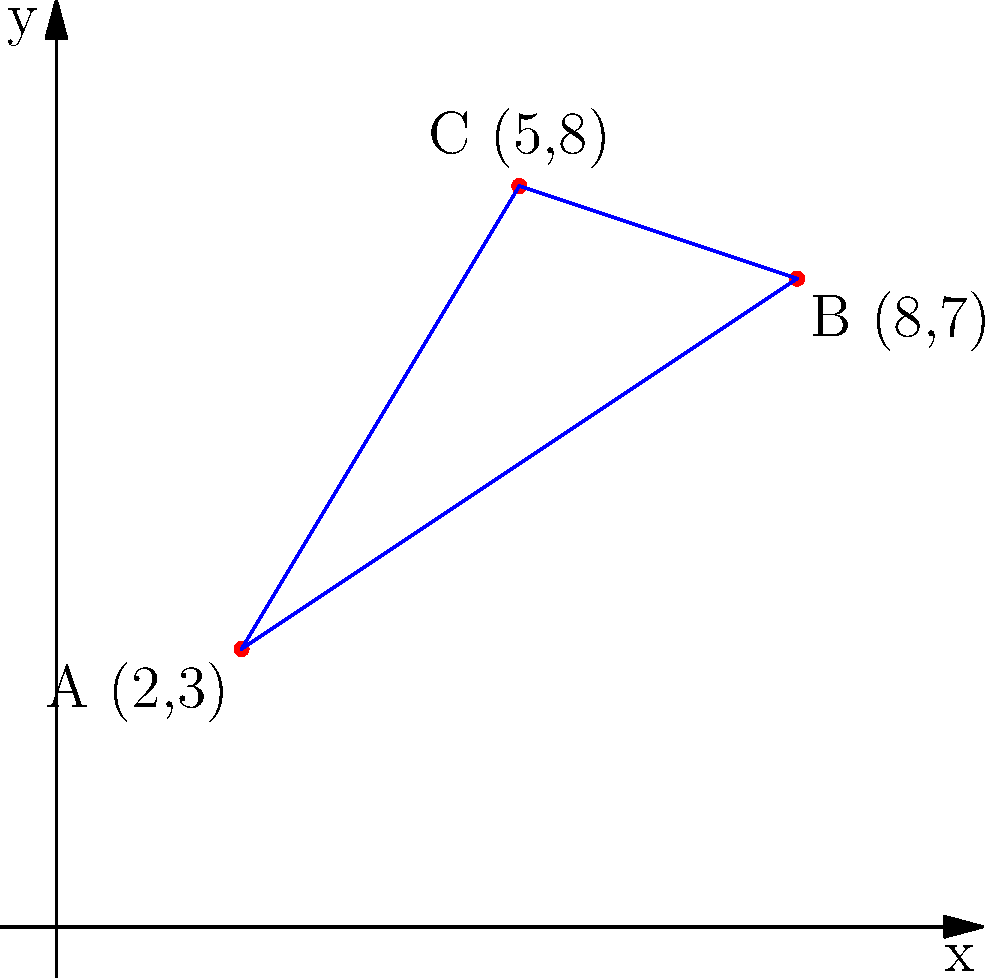Three rubber processing facilities are located at points A(2,3), B(8,7), and C(5,8) on a coordinate grid. To optimize transportation routes, you need to find the shortest path connecting all three facilities. What is the total length of this optimal path to the nearest tenth of a unit? To find the shortest path connecting all three facilities, we need to calculate the distances between each pair of points and find the sum of the two shortest distances. This will form a path that connects all three points with the minimum total distance.

Step 1: Calculate the distance between each pair of points using the distance formula:
$d = \sqrt{(x_2-x_1)^2 + (y_2-y_1)^2}$

Distance AB: $d_{AB} = \sqrt{(8-2)^2 + (7-3)^2} = \sqrt{36 + 16} = \sqrt{52} \approx 7.21$ units

Distance BC: $d_{BC} = \sqrt{(5-8)^2 + (8-7)^2} = \sqrt{9 + 1} = \sqrt{10} \approx 3.16$ units

Distance AC: $d_{AC} = \sqrt{(5-2)^2 + (8-3)^2} = \sqrt{9 + 25} = \sqrt{34} \approx 5.83$ units

Step 2: Identify the two shortest distances:
The two shortest distances are BC (3.16 units) and AC (5.83 units).

Step 3: Calculate the total length of the optimal path:
Total length = BC + AC = 3.16 + 5.83 = 8.99 units

Step 4: Round to the nearest tenth:
8.99 rounds to 9.0 units.
Answer: 9.0 units 